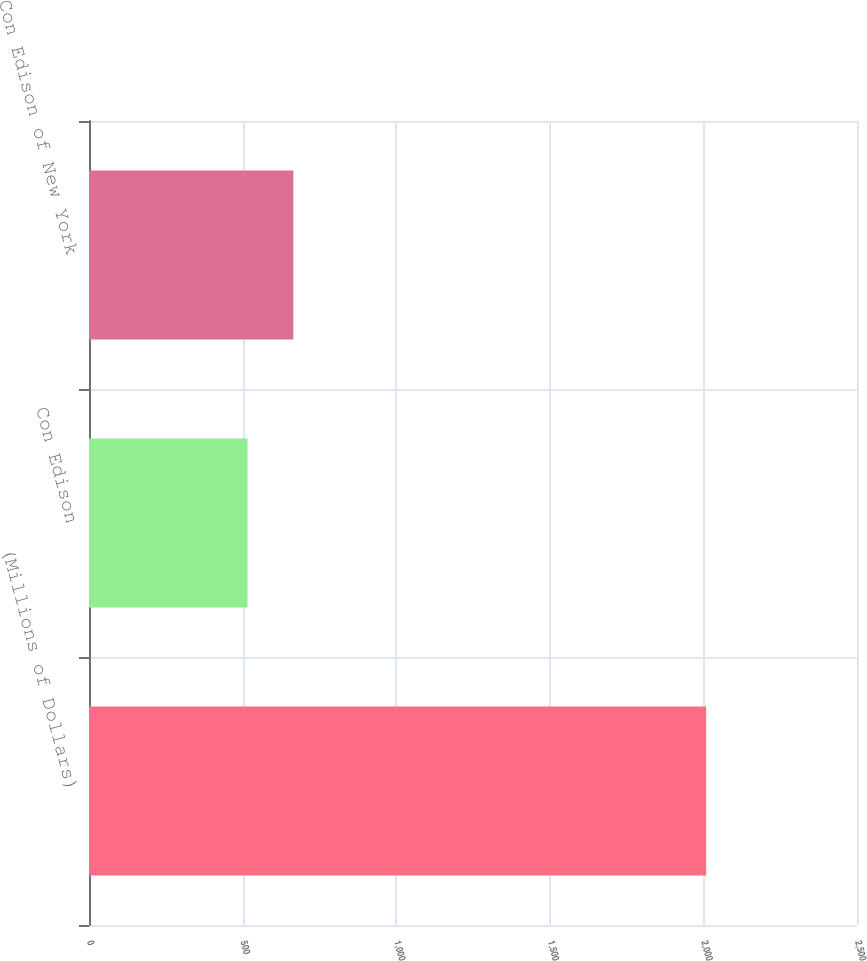<chart> <loc_0><loc_0><loc_500><loc_500><bar_chart><fcel>(Millions of Dollars)<fcel>Con Edison<fcel>Con Edison of New York<nl><fcel>2009<fcel>516<fcel>665.3<nl></chart> 